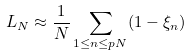<formula> <loc_0><loc_0><loc_500><loc_500>L _ { N } \approx \frac { 1 } { N } \sum _ { 1 \leq n \leq p N } ( 1 - \xi _ { n } )</formula> 